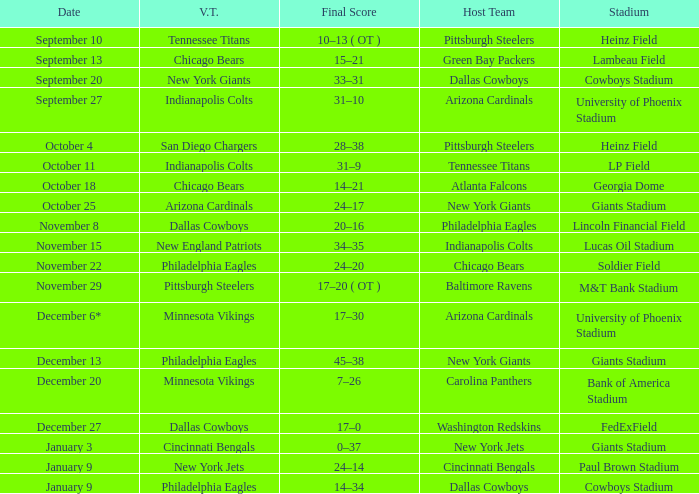Tell me the host team for giants stadium and visiting of cincinnati bengals New York Jets. 